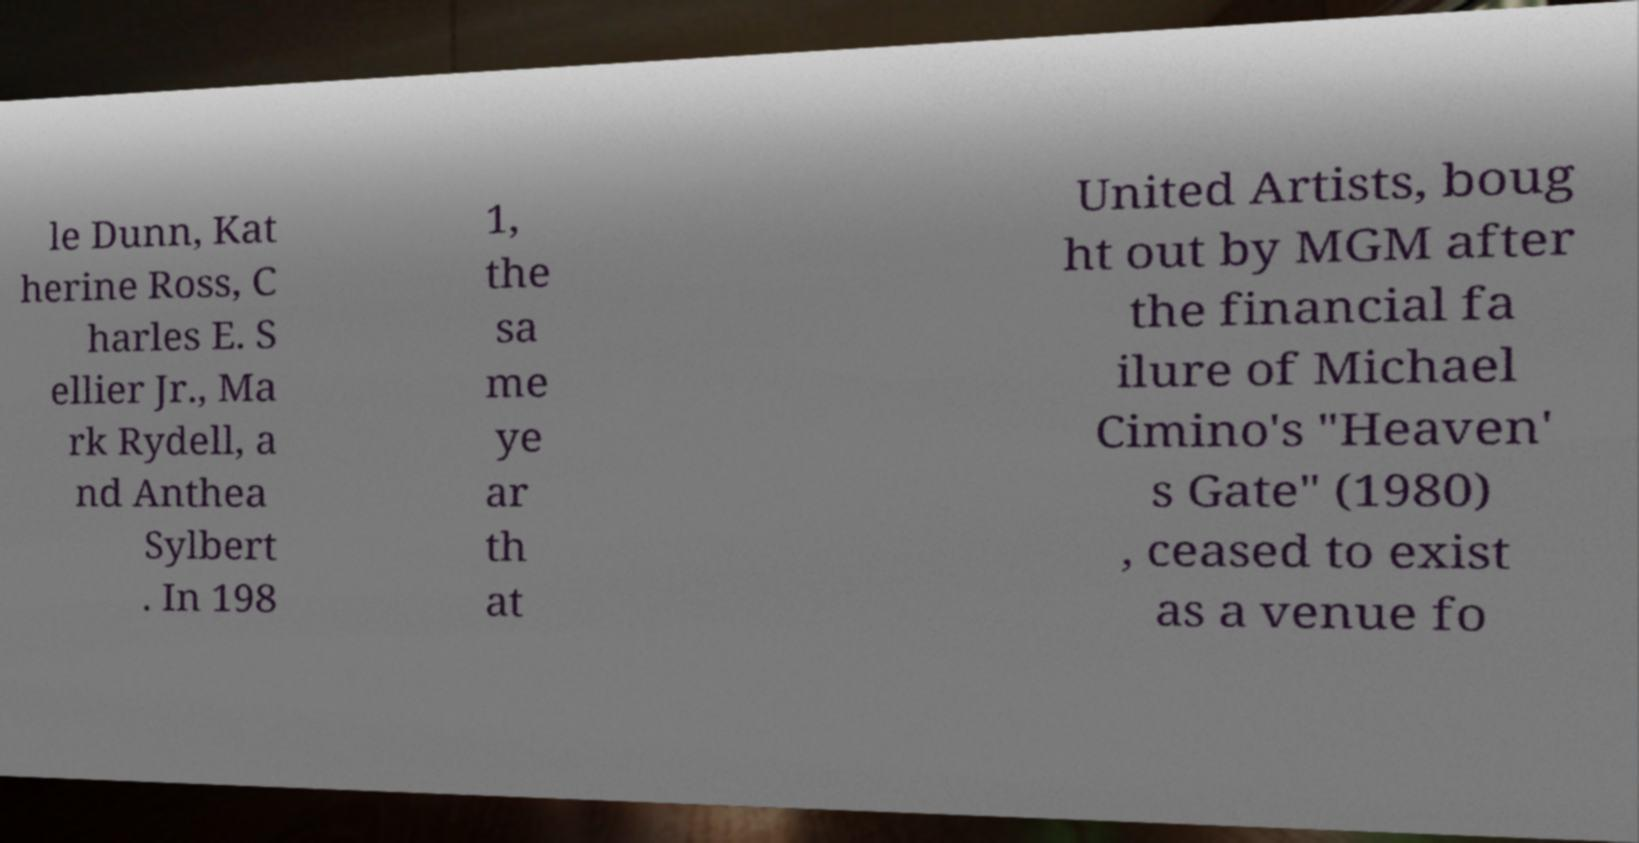Can you accurately transcribe the text from the provided image for me? le Dunn, Kat herine Ross, C harles E. S ellier Jr., Ma rk Rydell, a nd Anthea Sylbert . In 198 1, the sa me ye ar th at United Artists, boug ht out by MGM after the financial fa ilure of Michael Cimino's "Heaven' s Gate" (1980) , ceased to exist as a venue fo 